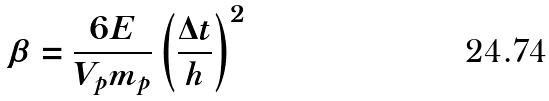Convert formula to latex. <formula><loc_0><loc_0><loc_500><loc_500>\beta = \frac { 6 E } { V _ { p } m _ { p } } \left ( \frac { \Delta t } { h } \right ) ^ { 2 }</formula> 